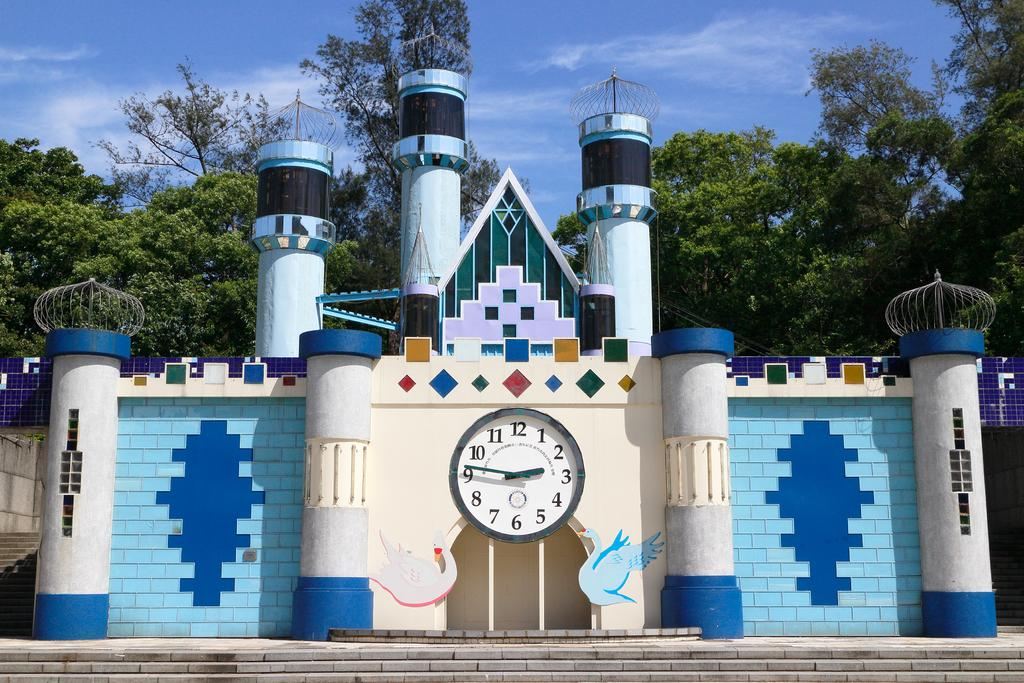<image>
Share a concise interpretation of the image provided. A castle ouside with a clock in the middle of it and the clock has the number 12 on it. 